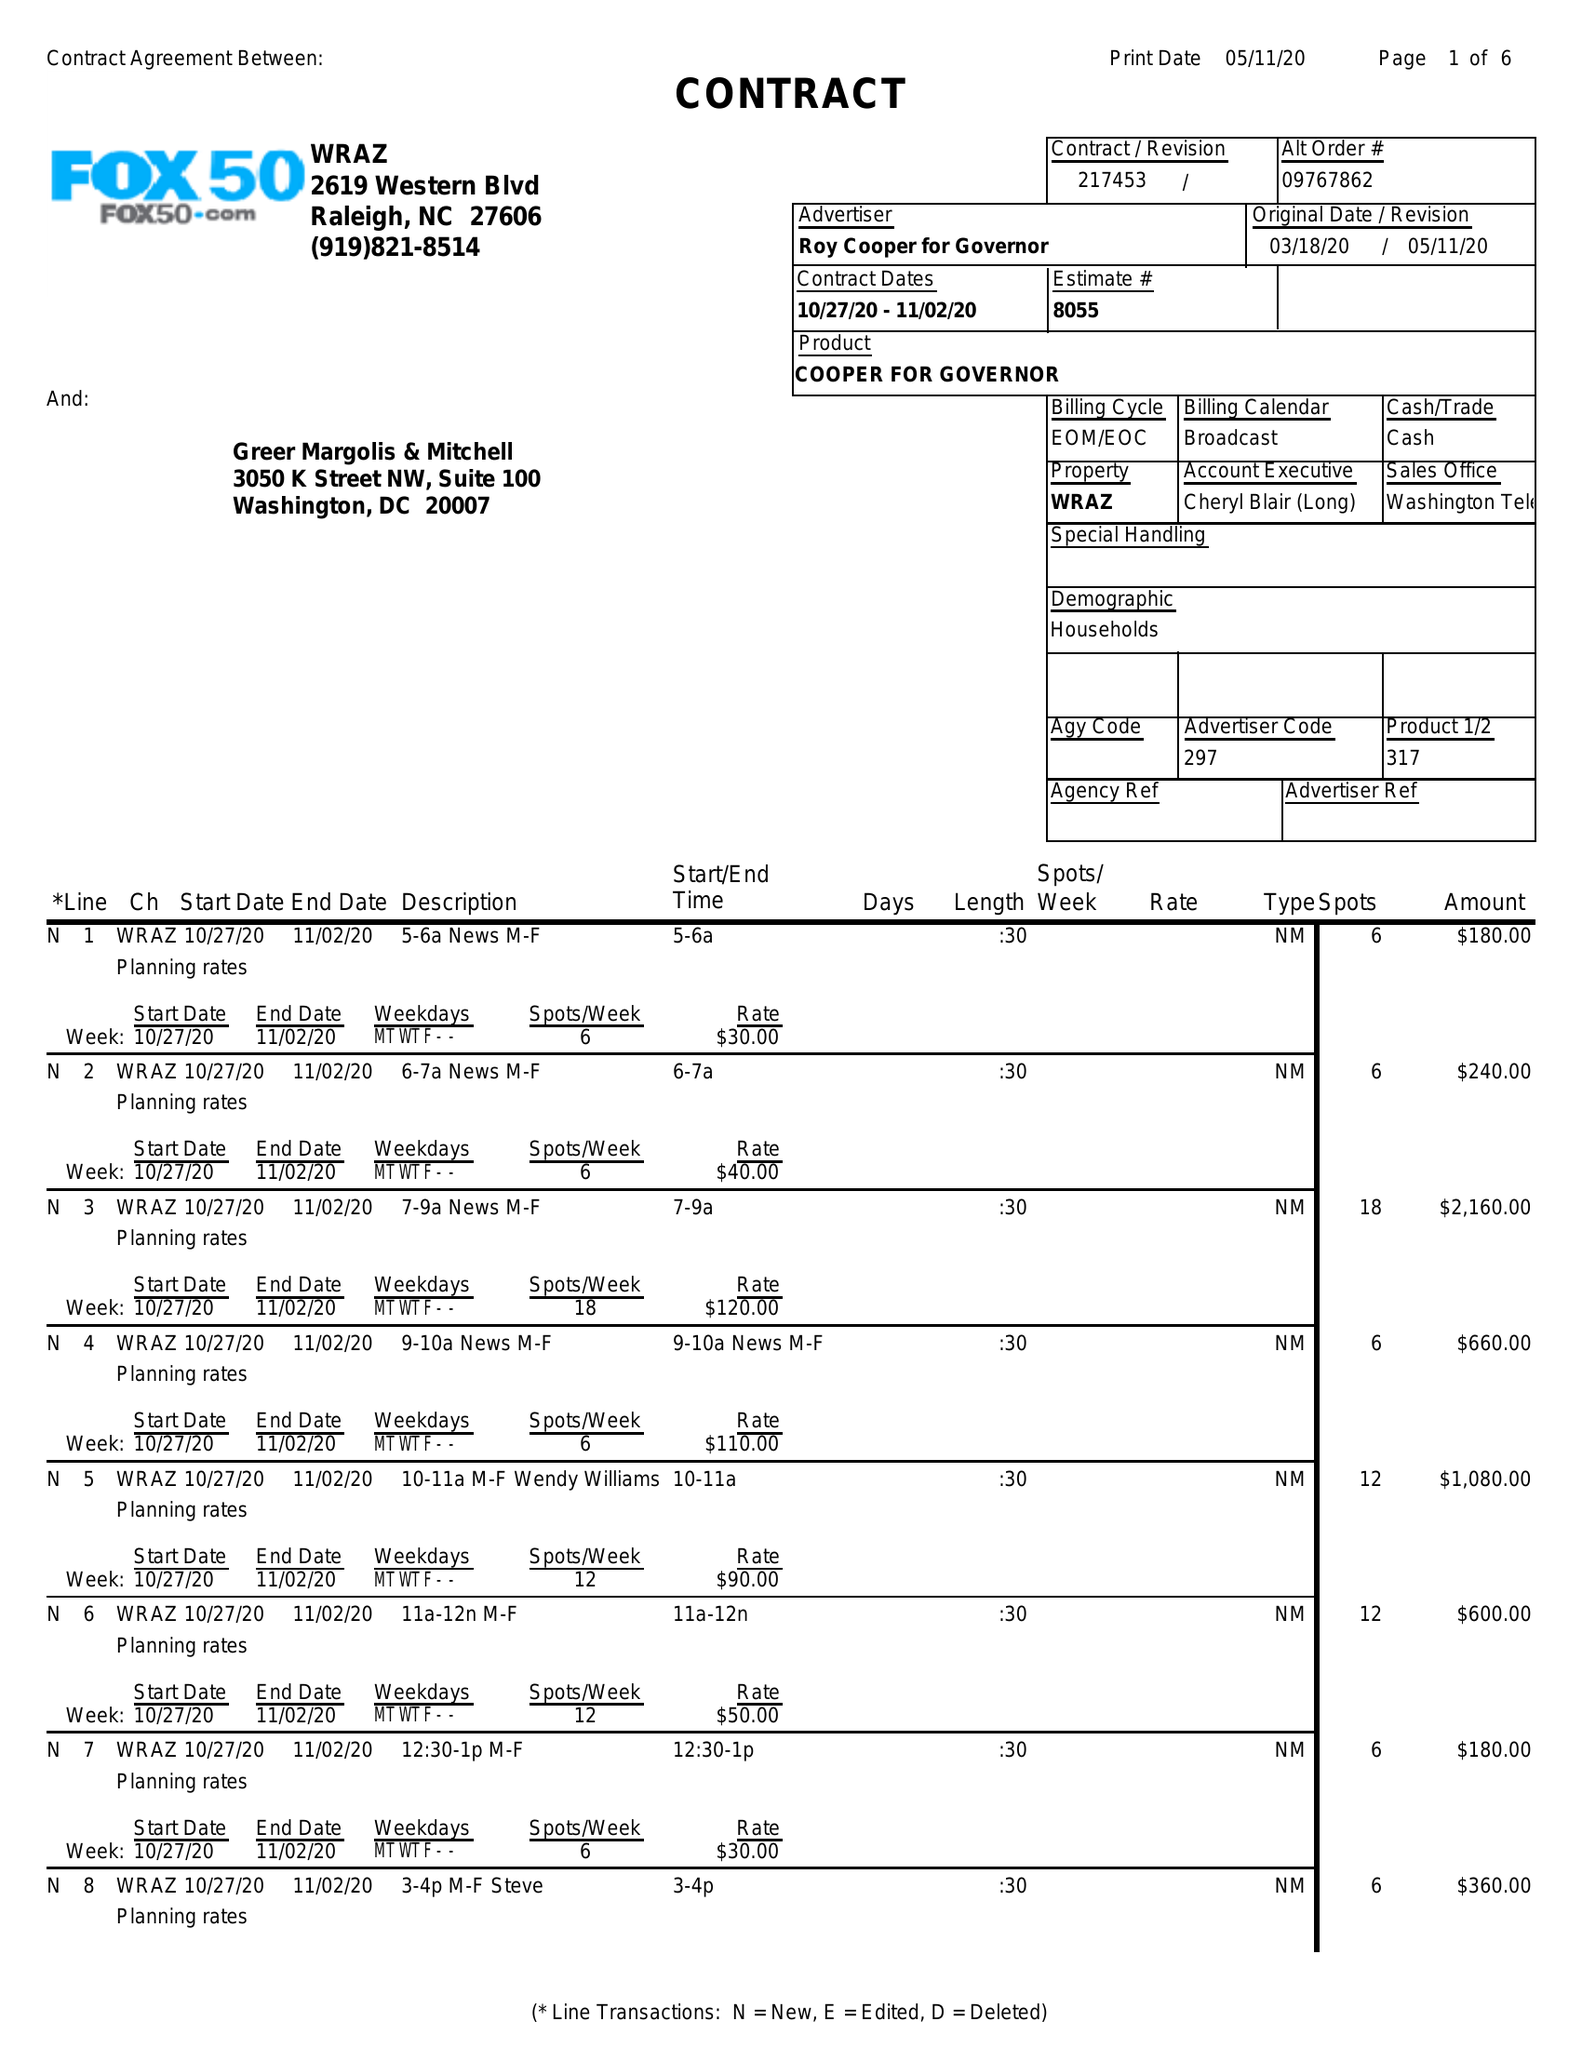What is the value for the flight_to?
Answer the question using a single word or phrase. 11/02/20 